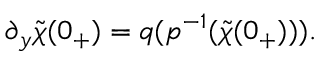Convert formula to latex. <formula><loc_0><loc_0><loc_500><loc_500>\partial _ { y } \tilde { \chi } ( 0 _ { + } ) = q ( p ^ { - 1 } ( \tilde { \chi } ( 0 _ { + } ) ) ) .</formula> 